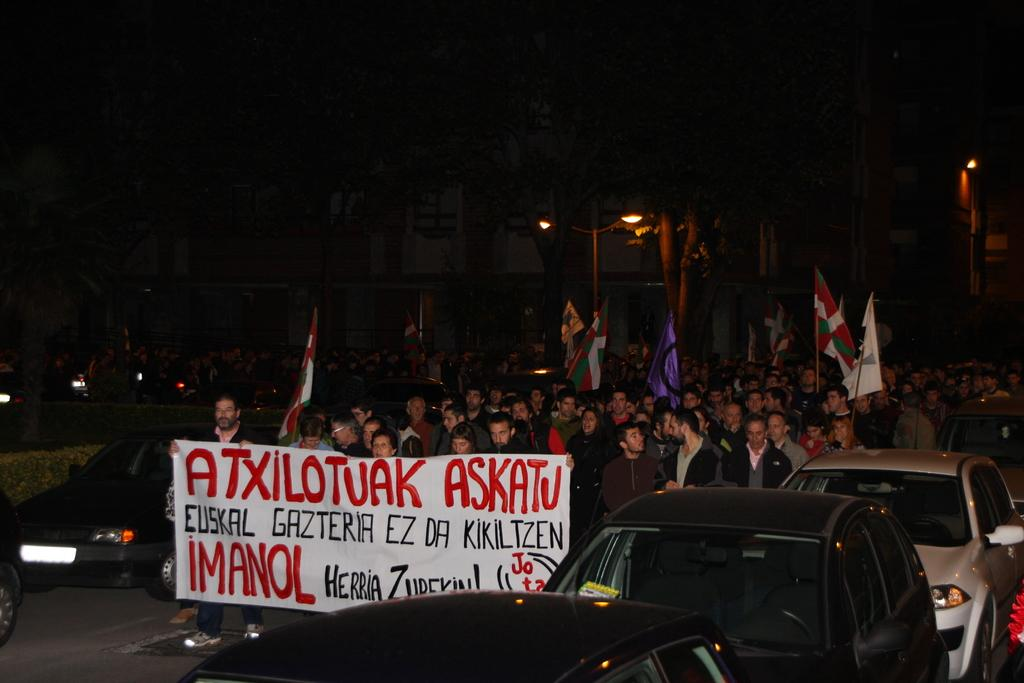What are the people in the center of the image doing? The people in the center of the image are walking. What are the people holding while walking? The people are holding flags and a banner. What type of vehicles can be seen in the image? There are cars in the image. What is one object that provides illumination in the image? There is a street light in the image. Can you tell me what book the people are reading in the image? There is no book present in the image; the people are holding flags and a banner. What type of kitchen appliance can be seen in the image? There is no kitchen appliance present in the image. 